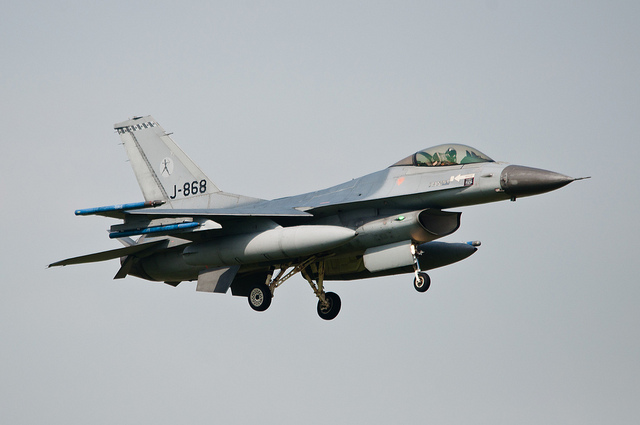Please transcribe the text information in this image. J 868 